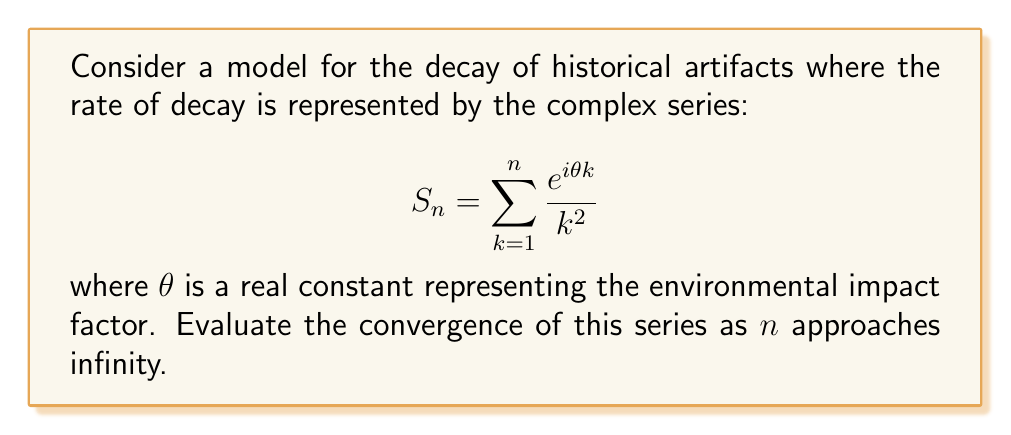Show me your answer to this math problem. To evaluate the convergence of this complex series, we'll follow these steps:

1) First, we need to recognize that this is a power series of the form $\sum_{k=1}^{\infty} a_k$ where $a_k = \frac{e^{i\theta k}}{k^2}$.

2) To test for convergence, we can use the comparison test with the p-series $\sum_{k=1}^{\infty} \frac{1}{k^2}$.

3) We know that $|e^{i\theta k}| = 1$ for all real $\theta$ and $k$. Therefore:

   $$ \left|\frac{e^{i\theta k}}{k^2}\right| = \frac{|e^{i\theta k}|}{k^2} = \frac{1}{k^2} $$

4) The p-series $\sum_{k=1}^{\infty} \frac{1}{k^2}$ converges for $p > 1$. In our case, $p = 2 > 1$.

5) By the comparison test, since $\left|\frac{e^{i\theta k}}{k^2}\right| \leq \frac{1}{k^2}$ for all $k$, and $\sum_{k=1}^{\infty} \frac{1}{k^2}$ converges, our original series $\sum_{k=1}^{\infty} \frac{e^{i\theta k}}{k^2}$ also converges.

6) This convergence is absolute, meaning it converges regardless of the value of $\theta$.

Therefore, the series converges for all real values of $\theta$, making it a suitable model for artifact decay under various environmental conditions.
Answer: The series converges absolutely for all real $\theta$. 